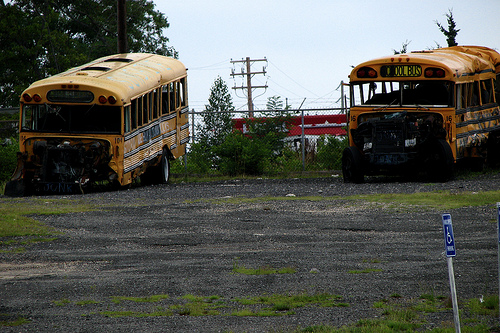What are the possible reasons for the buses being parked and abandoned in such a condition? The buses might be parked and left in disrepair due to obsolescence, lack of funding for repairs, or they could be awaiting salvage or recycling. The presence of grass and weeds around them suggests they have not been moved for a long time. 